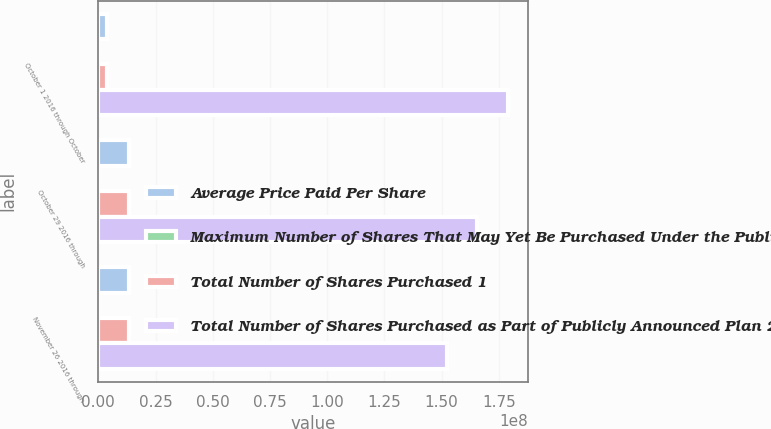<chart> <loc_0><loc_0><loc_500><loc_500><stacked_bar_chart><ecel><fcel>October 1 2016 through October<fcel>October 29 2016 through<fcel>November 26 2016 through<nl><fcel>Average Price Paid Per Share<fcel>3.67491e+06<fcel>1.33915e+07<fcel>1.32028e+07<nl><fcel>Maximum Number of Shares That May Yet Be Purchased Under the Publicly Announced Plan<fcel>42.1<fcel>41.71<fcel>41.42<nl><fcel>Total Number of Shares Purchased 1<fcel>3.67315e+06<fcel>1.33443e+07<fcel>1.32021e+07<nl><fcel>Total Number of Shares Purchased as Part of Publicly Announced Plan 2<fcel>1.78901e+08<fcel>1.65557e+08<fcel>1.52355e+08<nl></chart> 